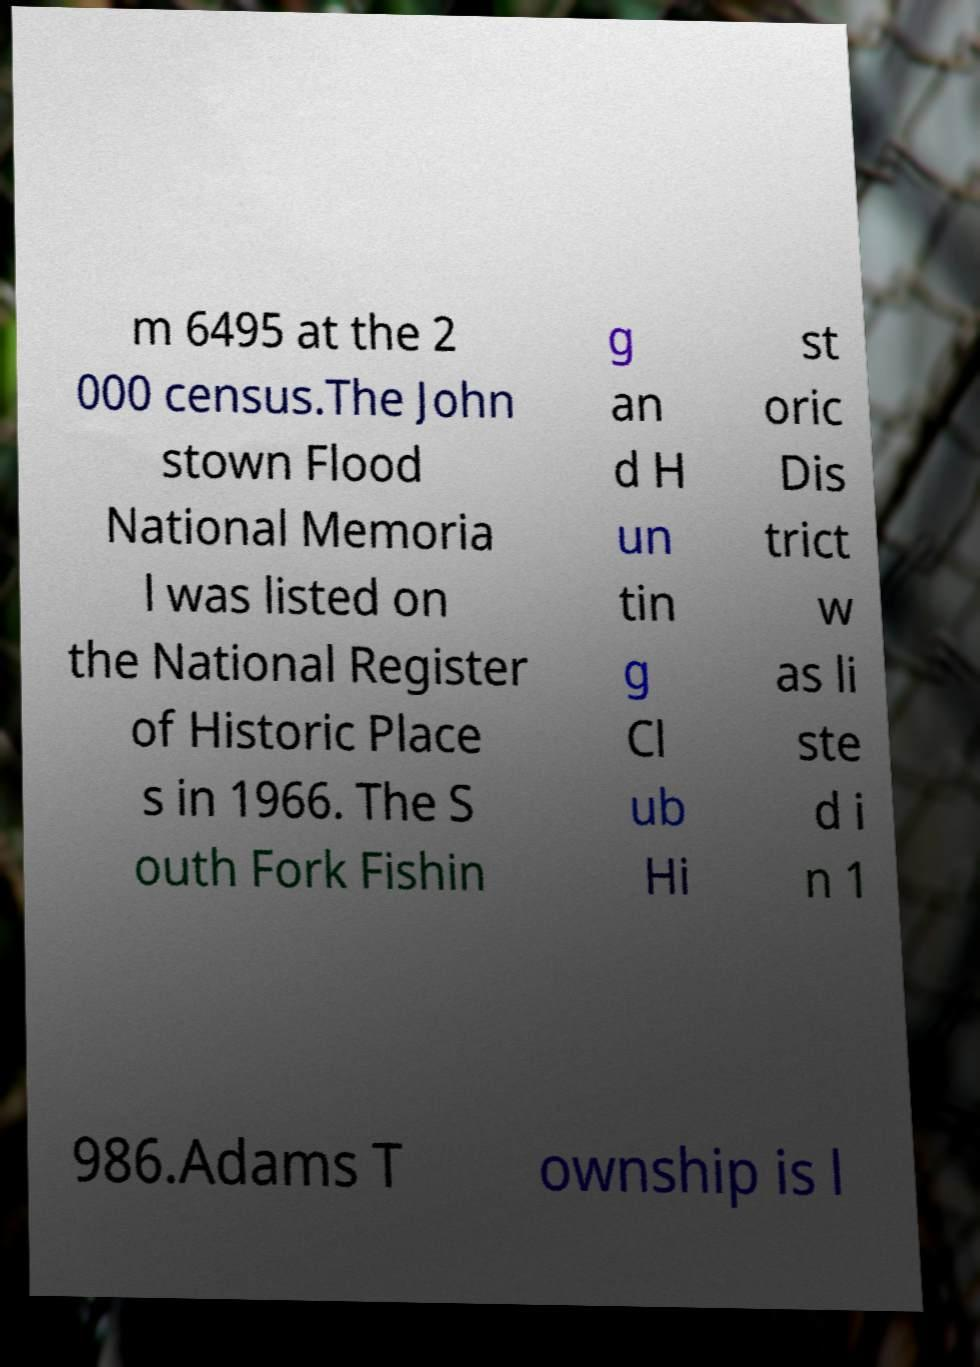For documentation purposes, I need the text within this image transcribed. Could you provide that? m 6495 at the 2 000 census.The John stown Flood National Memoria l was listed on the National Register of Historic Place s in 1966. The S outh Fork Fishin g an d H un tin g Cl ub Hi st oric Dis trict w as li ste d i n 1 986.Adams T ownship is l 